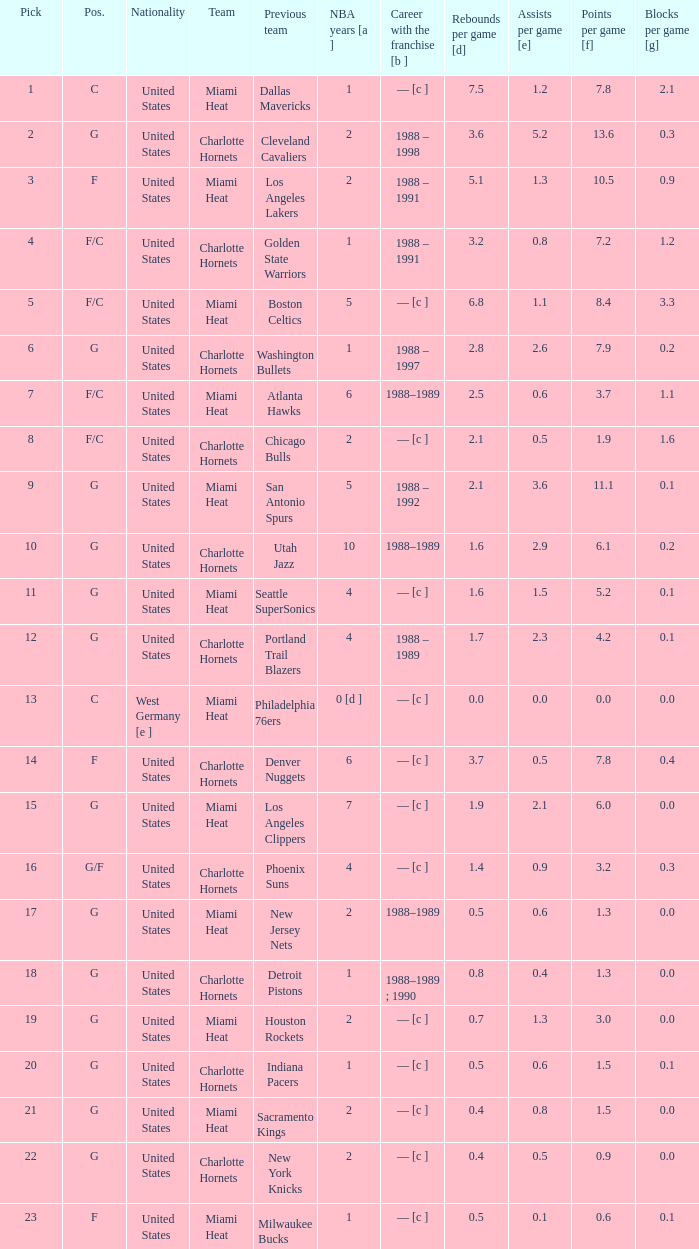How many NBA years did the player from the United States who was previously on the los angeles lakers have? 2.0. 